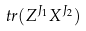<formula> <loc_0><loc_0><loc_500><loc_500>\ t r ( Z ^ { J _ { 1 } } X ^ { J _ { 2 } } )</formula> 